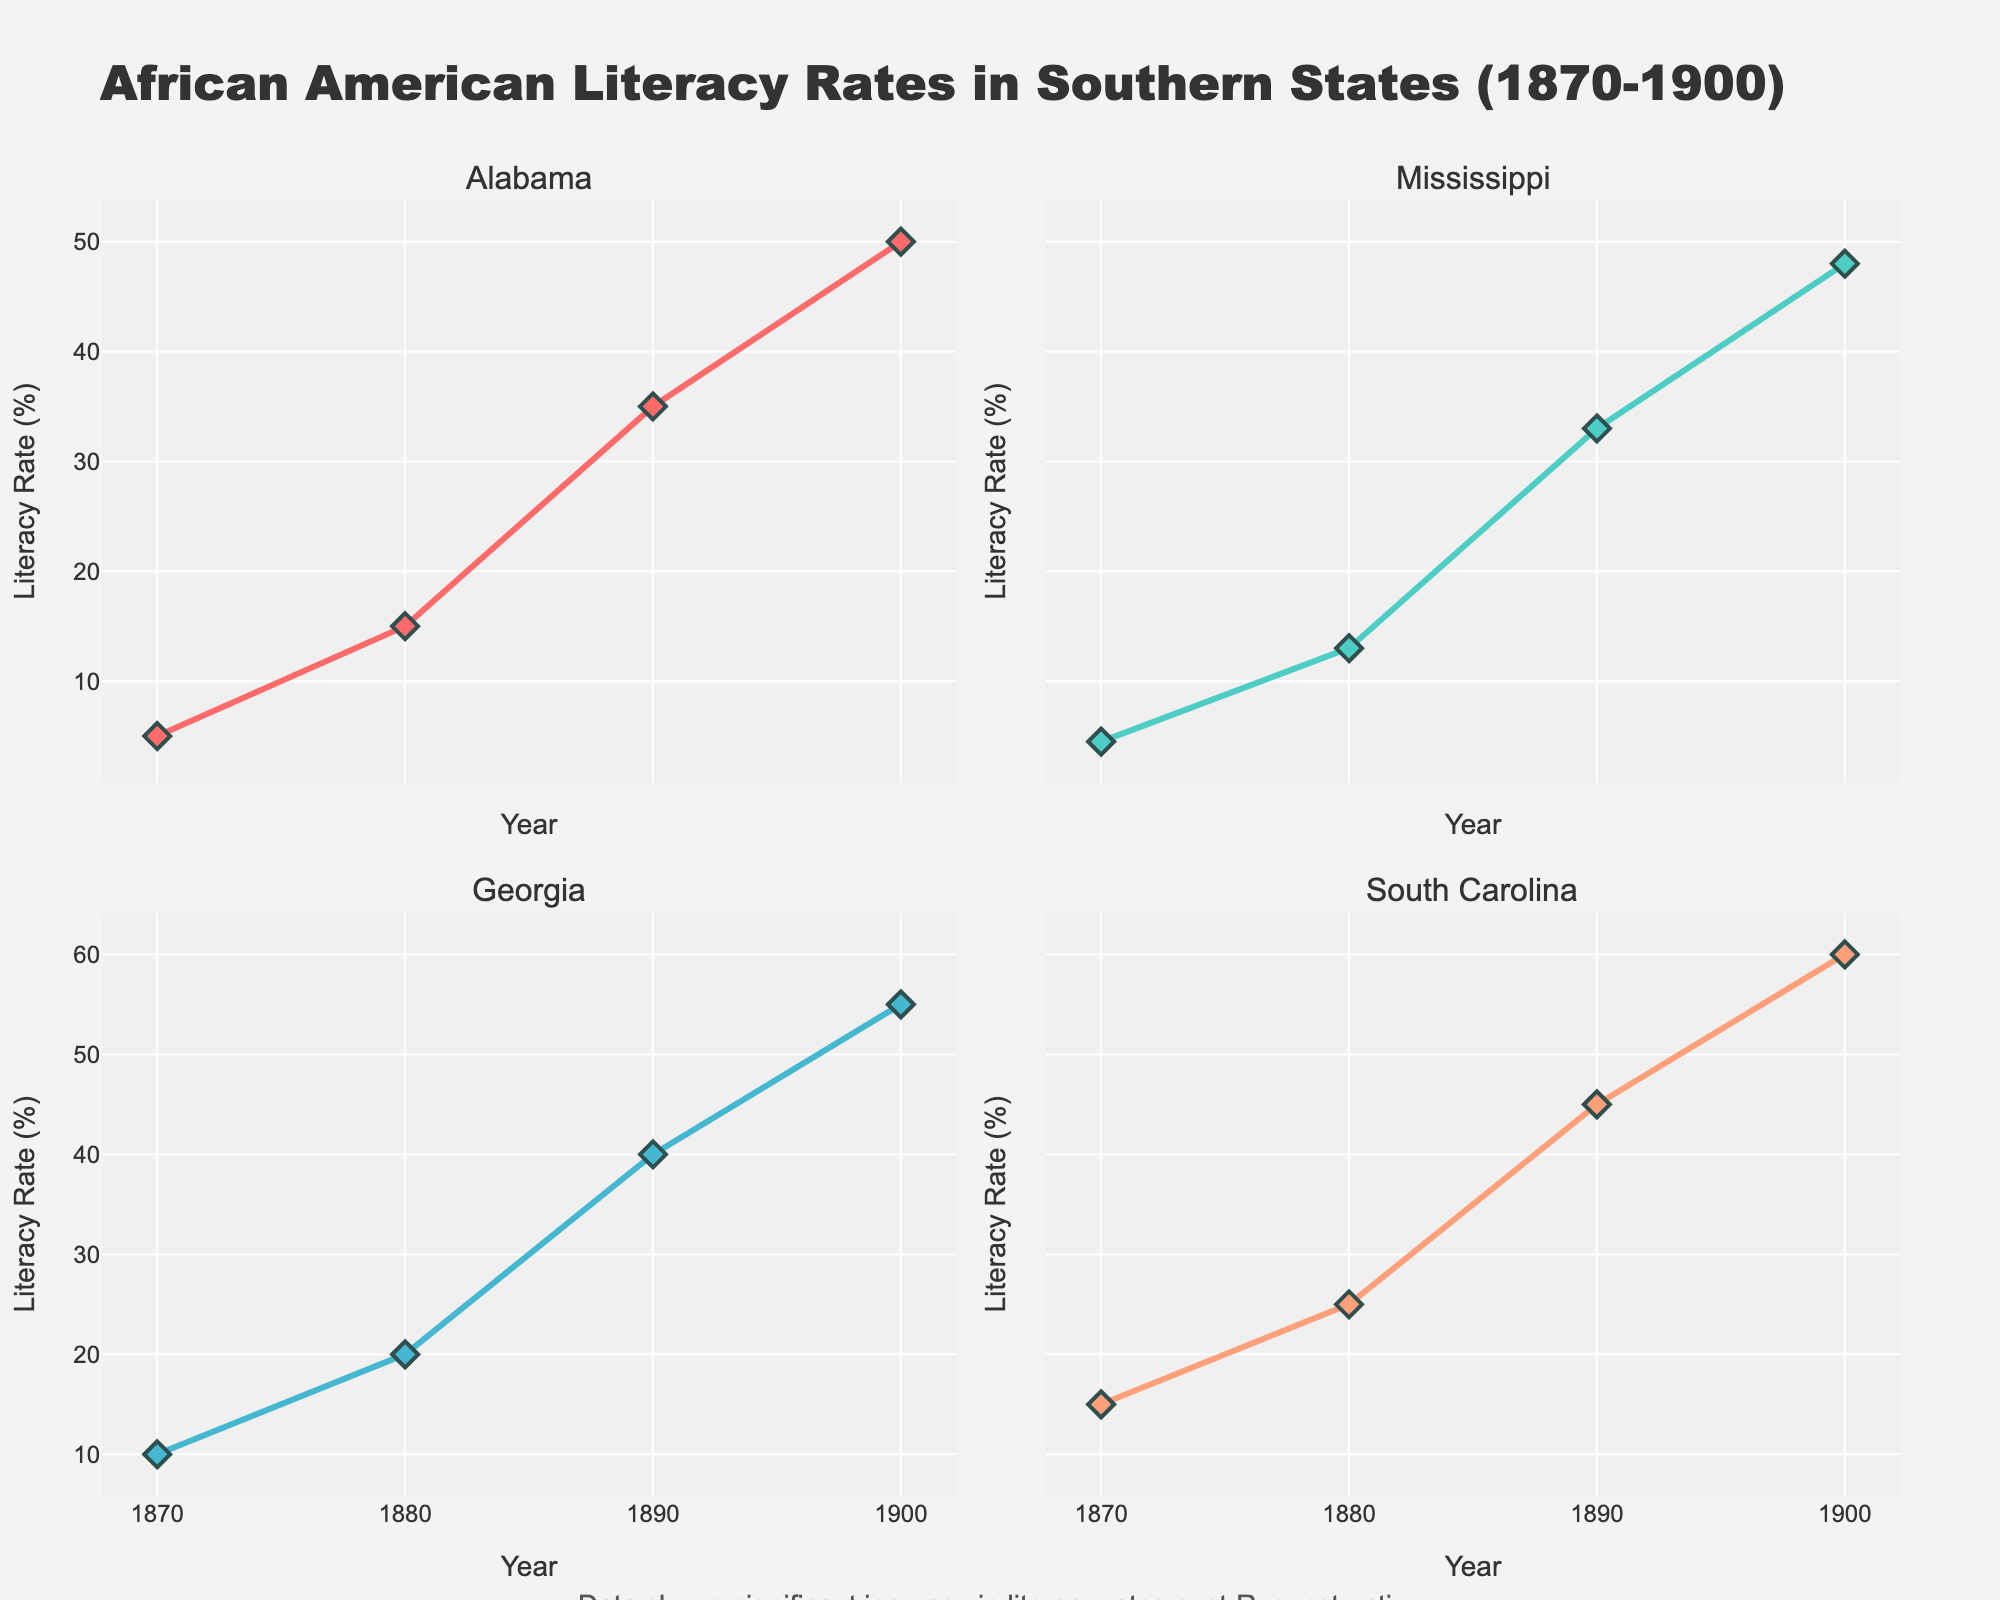What is the title of the figure? The title is displayed at the top of the figure.
Answer: African American Literacy Rates in Southern States (1870-1900) In which year did South Carolina have a literacy rate of about 60%? Locate the line representing South Carolina in its subplot and identify the year corresponding to a literacy rate of 60%.
Answer: 1900 Which state had the lowest literacy rate in 1870? Compare the literacy rates across all states in the year 1870 by looking at the markers on the x-axis corresponding to 1870.
Answer: Mississippi How does the increase in literacy rates from 1870 to 1900 compare between Alabama and Georgia? Calculate the difference in literacy rates for both states between 1870 and 1900 (Alabama: 50%, Georgia: 40%) and compare them.
Answer: Alabama: 45%, Georgia: 45% Which state shows the most significant improvement in literacy rate from 1870 to 1900? Compare the differences in literacy rates for all the states between 1870 and 1900 and identify the state with the greatest increase.
Answer: South Carolina What is the average literacy rate of Mississippi across all the years shown in the figure? Find the literacy rates for Mississippi for the years 1870, 1880, 1890, and 1900 (4.5%, 13%, 33%, 48%), sum them up, and divide by 4.
Answer: 24.625% Which state had the highest literacy rate in 1890? Compare the literacy rates for all states in the year 1890 and identify the highest.
Answer: South Carolina How does the literacy rate trend over the years compare between Mississippi and Louisiana? Observe the lines for Mississippi and Louisiana and compare the slopes and trends from 1870 to 1900 visually.
Answer: Both show a steep increase, but Mississippi starts lower and ends slightly lower What is the approximate difference in literacy rates between Georgia and Alabama in 1880? Find and subtract the literacy rate of Alabama in 1880 (15%) from the literacy rate of Georgia in 1880 (20%).
Answer: 5% Which subplot shows the steepest increase in literacy rate? Compare the gradients of the lines in all subplots to determine which has the most noticeable upward trend.
Answer: South Carolina 